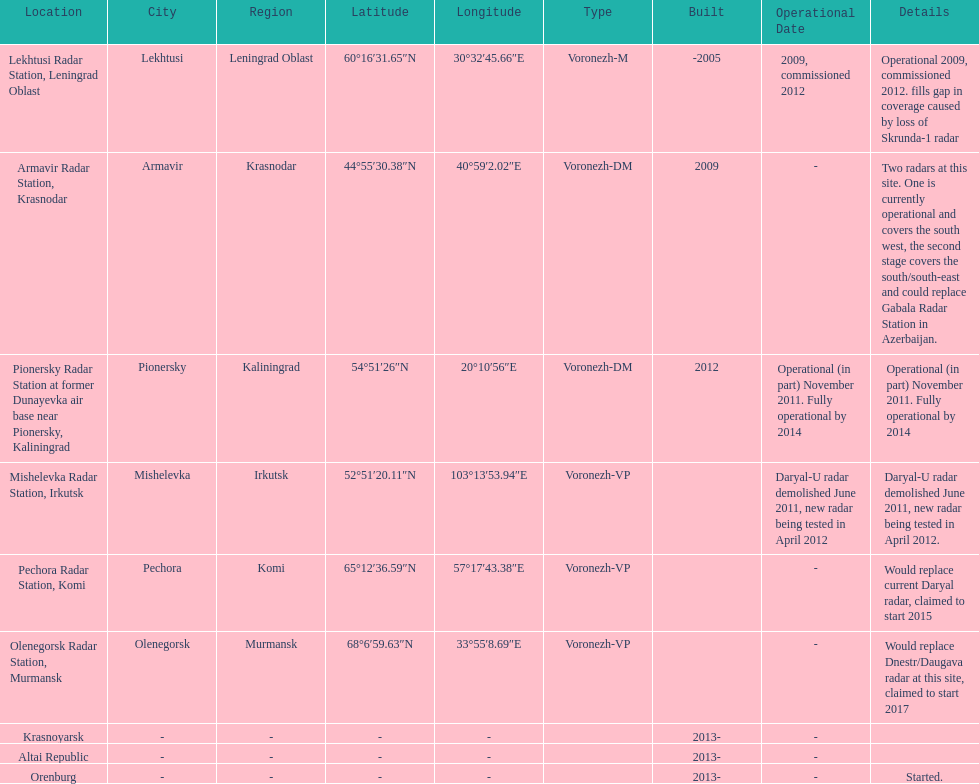How many voronezh radars are in kaliningrad or in krasnodar? 2. 